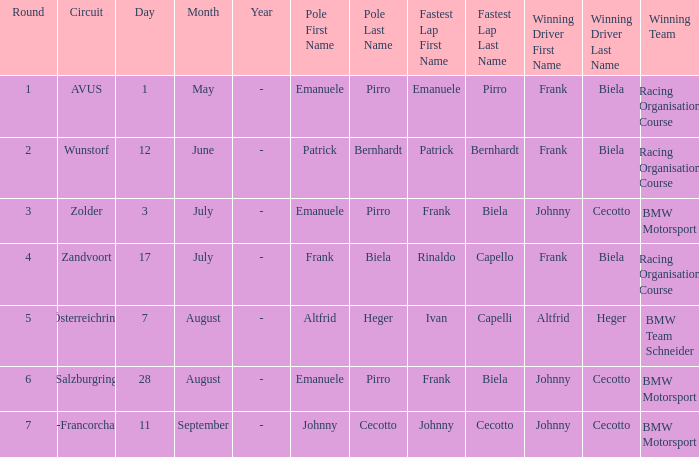Who was the winning team on the circuit Zolder? BMW Motorsport. 